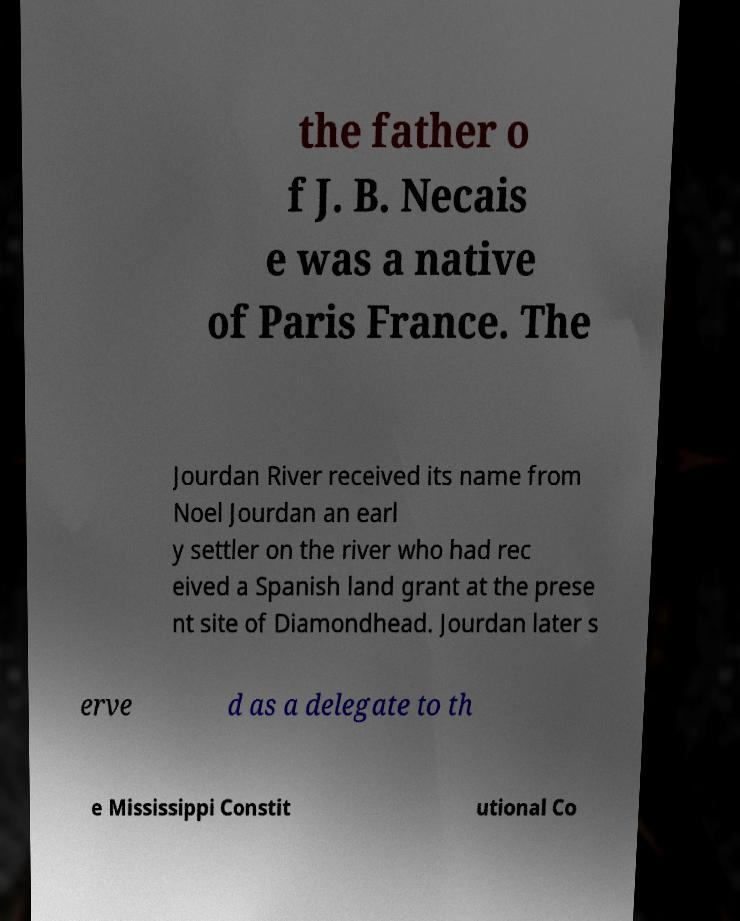What messages or text are displayed in this image? I need them in a readable, typed format. the father o f J. B. Necais e was a native of Paris France. The Jourdan River received its name from Noel Jourdan an earl y settler on the river who had rec eived a Spanish land grant at the prese nt site of Diamondhead. Jourdan later s erve d as a delegate to th e Mississippi Constit utional Co 